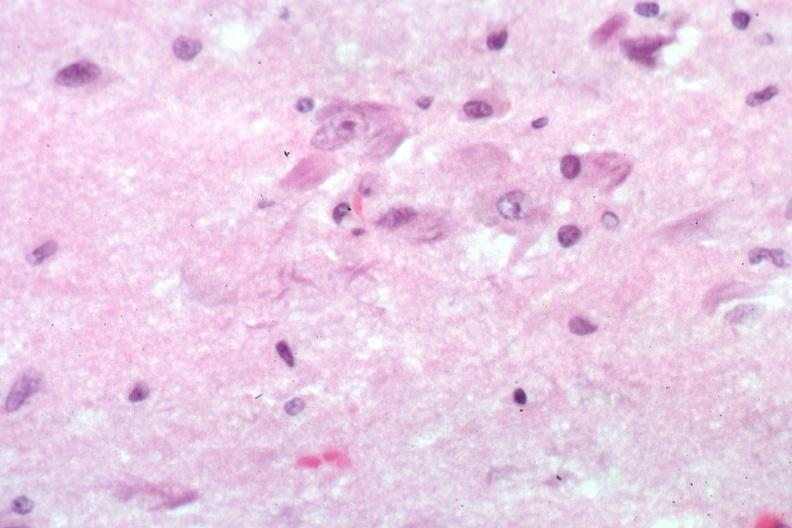s brain present?
Answer the question using a single word or phrase. Yes 